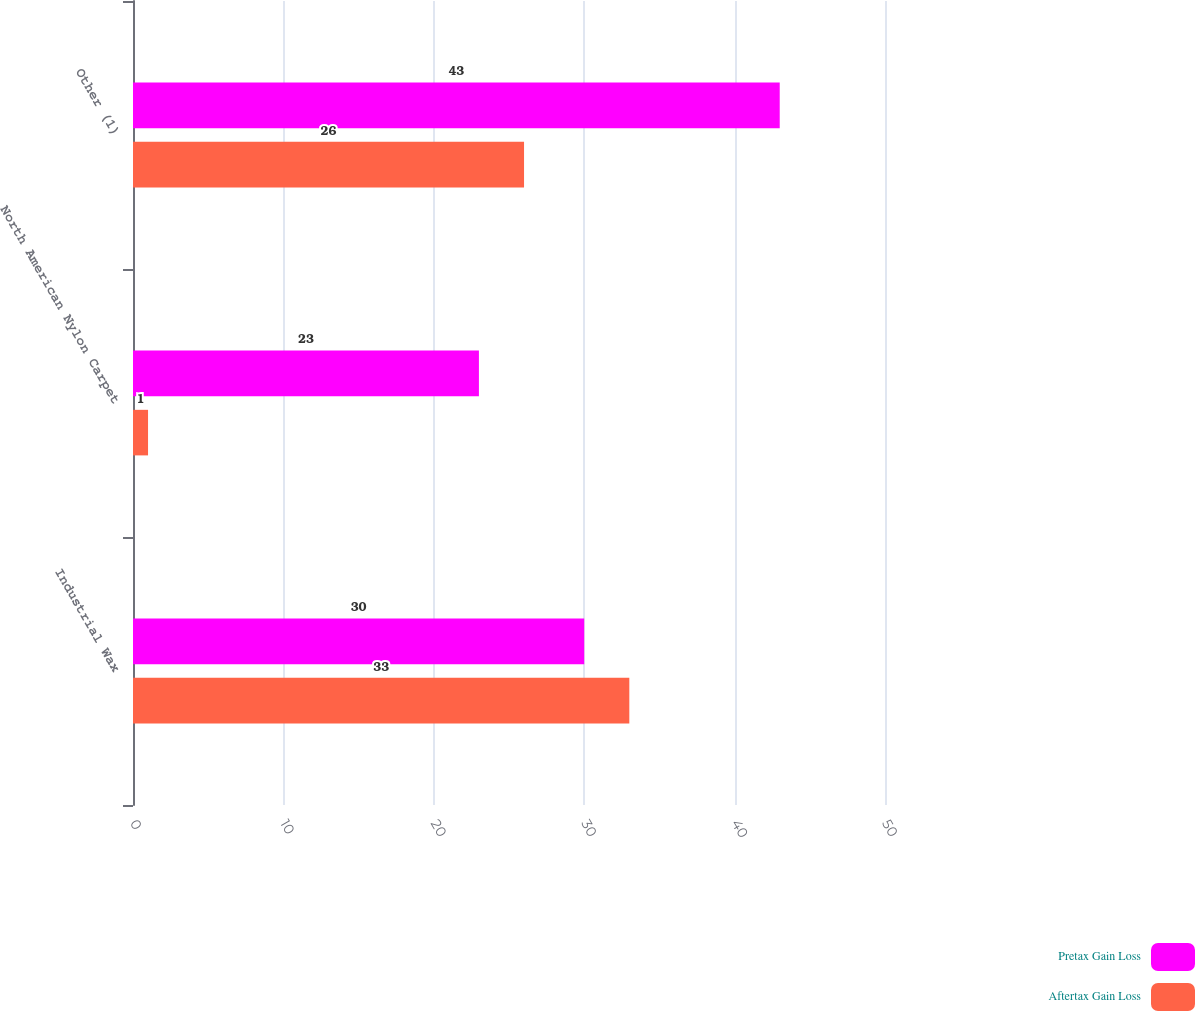Convert chart. <chart><loc_0><loc_0><loc_500><loc_500><stacked_bar_chart><ecel><fcel>Industrial Wax<fcel>North American Nylon Carpet<fcel>Other (1)<nl><fcel>Pretax Gain Loss<fcel>30<fcel>23<fcel>43<nl><fcel>Aftertax Gain Loss<fcel>33<fcel>1<fcel>26<nl></chart> 